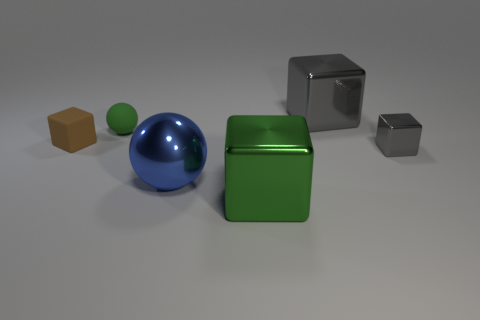Is the tiny sphere the same color as the small rubber block?
Ensure brevity in your answer.  No. What is the size of the sphere that is the same material as the green cube?
Provide a short and direct response. Large. What number of tiny green matte objects are the same shape as the blue metallic thing?
Keep it short and to the point. 1. There is a blue metal object; does it have the same shape as the tiny thing to the right of the tiny green thing?
Offer a very short reply. No. What is the shape of the large shiny object that is the same color as the tiny sphere?
Ensure brevity in your answer.  Cube. Is there a ball made of the same material as the brown block?
Make the answer very short. Yes. Are there any other things that are the same material as the large green cube?
Ensure brevity in your answer.  Yes. What material is the gray object that is on the left side of the gray object that is in front of the small rubber sphere?
Make the answer very short. Metal. There is a gray metallic cube that is in front of the big shiny cube that is behind the gray metal block right of the big gray thing; what is its size?
Keep it short and to the point. Small. What number of other objects are the same shape as the tiny brown matte thing?
Provide a short and direct response. 3. 